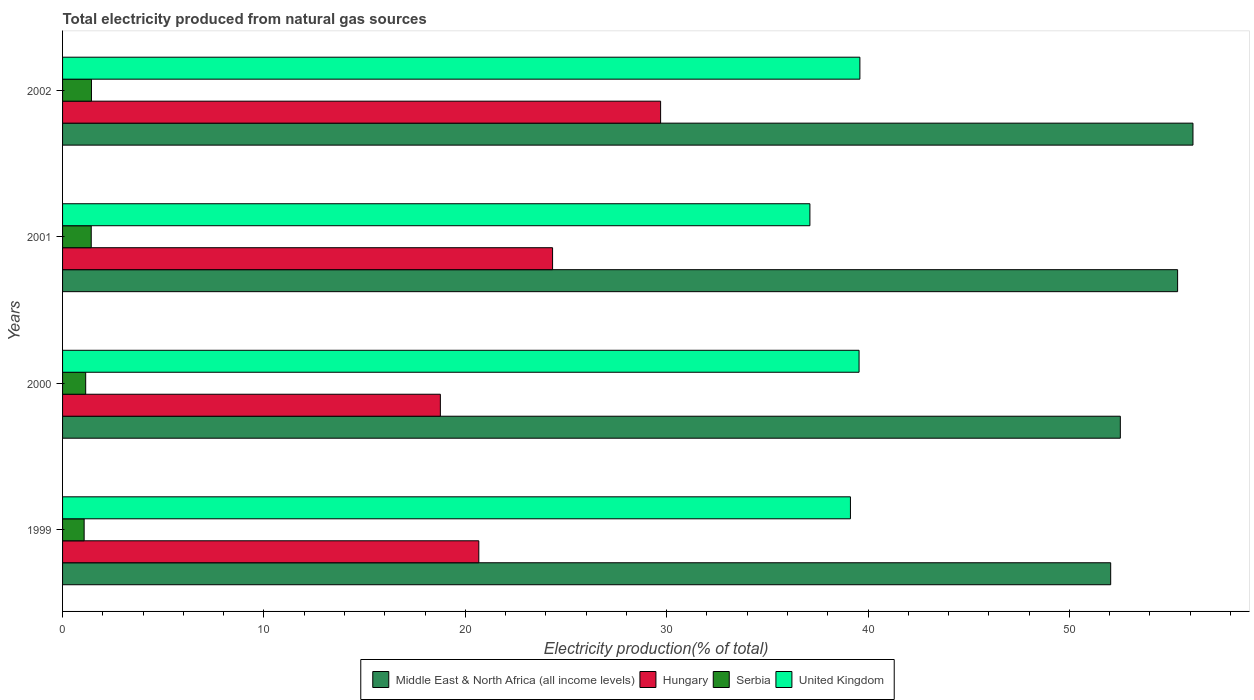How many bars are there on the 3rd tick from the bottom?
Give a very brief answer. 4. What is the label of the 2nd group of bars from the top?
Your response must be concise. 2001. In how many cases, is the number of bars for a given year not equal to the number of legend labels?
Provide a succinct answer. 0. What is the total electricity produced in Serbia in 1999?
Provide a succinct answer. 1.07. Across all years, what is the maximum total electricity produced in Hungary?
Give a very brief answer. 29.7. Across all years, what is the minimum total electricity produced in Middle East & North Africa (all income levels)?
Your answer should be compact. 52.05. In which year was the total electricity produced in Serbia maximum?
Offer a very short reply. 2002. In which year was the total electricity produced in Serbia minimum?
Your answer should be very brief. 1999. What is the total total electricity produced in United Kingdom in the graph?
Provide a succinct answer. 155.38. What is the difference between the total electricity produced in Hungary in 1999 and that in 2002?
Ensure brevity in your answer.  -9.03. What is the difference between the total electricity produced in Serbia in 1999 and the total electricity produced in Hungary in 2002?
Offer a terse response. -28.63. What is the average total electricity produced in Hungary per year?
Keep it short and to the point. 23.37. In the year 2000, what is the difference between the total electricity produced in Middle East & North Africa (all income levels) and total electricity produced in United Kingdom?
Your answer should be compact. 12.97. In how many years, is the total electricity produced in Serbia greater than 24 %?
Offer a very short reply. 0. What is the ratio of the total electricity produced in United Kingdom in 1999 to that in 2000?
Make the answer very short. 0.99. Is the total electricity produced in United Kingdom in 2000 less than that in 2002?
Ensure brevity in your answer.  Yes. What is the difference between the highest and the second highest total electricity produced in Serbia?
Give a very brief answer. 0.01. What is the difference between the highest and the lowest total electricity produced in United Kingdom?
Ensure brevity in your answer.  2.48. In how many years, is the total electricity produced in United Kingdom greater than the average total electricity produced in United Kingdom taken over all years?
Give a very brief answer. 3. Is the sum of the total electricity produced in Middle East & North Africa (all income levels) in 1999 and 2001 greater than the maximum total electricity produced in Hungary across all years?
Your answer should be compact. Yes. What does the 2nd bar from the top in 2001 represents?
Your response must be concise. Serbia. What does the 4th bar from the bottom in 2000 represents?
Your response must be concise. United Kingdom. How many bars are there?
Keep it short and to the point. 16. How many years are there in the graph?
Make the answer very short. 4. What is the difference between two consecutive major ticks on the X-axis?
Give a very brief answer. 10. Does the graph contain grids?
Your answer should be very brief. No. Where does the legend appear in the graph?
Ensure brevity in your answer.  Bottom center. How many legend labels are there?
Keep it short and to the point. 4. What is the title of the graph?
Make the answer very short. Total electricity produced from natural gas sources. What is the label or title of the X-axis?
Keep it short and to the point. Electricity production(% of total). What is the Electricity production(% of total) in Middle East & North Africa (all income levels) in 1999?
Your answer should be compact. 52.05. What is the Electricity production(% of total) of Hungary in 1999?
Give a very brief answer. 20.67. What is the Electricity production(% of total) in Serbia in 1999?
Ensure brevity in your answer.  1.07. What is the Electricity production(% of total) in United Kingdom in 1999?
Ensure brevity in your answer.  39.12. What is the Electricity production(% of total) in Middle East & North Africa (all income levels) in 2000?
Provide a succinct answer. 52.53. What is the Electricity production(% of total) of Hungary in 2000?
Your answer should be compact. 18.76. What is the Electricity production(% of total) of Serbia in 2000?
Offer a very short reply. 1.15. What is the Electricity production(% of total) in United Kingdom in 2000?
Provide a succinct answer. 39.55. What is the Electricity production(% of total) of Middle East & North Africa (all income levels) in 2001?
Make the answer very short. 55.37. What is the Electricity production(% of total) of Hungary in 2001?
Offer a very short reply. 24.33. What is the Electricity production(% of total) in Serbia in 2001?
Offer a terse response. 1.42. What is the Electricity production(% of total) of United Kingdom in 2001?
Offer a terse response. 37.11. What is the Electricity production(% of total) of Middle East & North Africa (all income levels) in 2002?
Offer a very short reply. 56.13. What is the Electricity production(% of total) in Hungary in 2002?
Offer a terse response. 29.7. What is the Electricity production(% of total) in Serbia in 2002?
Provide a short and direct response. 1.43. What is the Electricity production(% of total) in United Kingdom in 2002?
Provide a succinct answer. 39.59. Across all years, what is the maximum Electricity production(% of total) in Middle East & North Africa (all income levels)?
Offer a very short reply. 56.13. Across all years, what is the maximum Electricity production(% of total) in Hungary?
Give a very brief answer. 29.7. Across all years, what is the maximum Electricity production(% of total) in Serbia?
Ensure brevity in your answer.  1.43. Across all years, what is the maximum Electricity production(% of total) of United Kingdom?
Make the answer very short. 39.59. Across all years, what is the minimum Electricity production(% of total) in Middle East & North Africa (all income levels)?
Provide a short and direct response. 52.05. Across all years, what is the minimum Electricity production(% of total) of Hungary?
Ensure brevity in your answer.  18.76. Across all years, what is the minimum Electricity production(% of total) of Serbia?
Provide a short and direct response. 1.07. Across all years, what is the minimum Electricity production(% of total) in United Kingdom?
Keep it short and to the point. 37.11. What is the total Electricity production(% of total) in Middle East & North Africa (all income levels) in the graph?
Provide a succinct answer. 216.08. What is the total Electricity production(% of total) in Hungary in the graph?
Keep it short and to the point. 93.46. What is the total Electricity production(% of total) in Serbia in the graph?
Your answer should be very brief. 5.08. What is the total Electricity production(% of total) of United Kingdom in the graph?
Provide a succinct answer. 155.38. What is the difference between the Electricity production(% of total) of Middle East & North Africa (all income levels) in 1999 and that in 2000?
Your response must be concise. -0.48. What is the difference between the Electricity production(% of total) in Hungary in 1999 and that in 2000?
Give a very brief answer. 1.91. What is the difference between the Electricity production(% of total) of Serbia in 1999 and that in 2000?
Provide a succinct answer. -0.08. What is the difference between the Electricity production(% of total) of United Kingdom in 1999 and that in 2000?
Give a very brief answer. -0.43. What is the difference between the Electricity production(% of total) in Middle East & North Africa (all income levels) in 1999 and that in 2001?
Your answer should be very brief. -3.32. What is the difference between the Electricity production(% of total) in Hungary in 1999 and that in 2001?
Make the answer very short. -3.66. What is the difference between the Electricity production(% of total) of Serbia in 1999 and that in 2001?
Your answer should be compact. -0.35. What is the difference between the Electricity production(% of total) in United Kingdom in 1999 and that in 2001?
Give a very brief answer. 2.01. What is the difference between the Electricity production(% of total) of Middle East & North Africa (all income levels) in 1999 and that in 2002?
Provide a succinct answer. -4.09. What is the difference between the Electricity production(% of total) in Hungary in 1999 and that in 2002?
Your answer should be very brief. -9.03. What is the difference between the Electricity production(% of total) in Serbia in 1999 and that in 2002?
Offer a terse response. -0.36. What is the difference between the Electricity production(% of total) of United Kingdom in 1999 and that in 2002?
Make the answer very short. -0.47. What is the difference between the Electricity production(% of total) in Middle East & North Africa (all income levels) in 2000 and that in 2001?
Provide a succinct answer. -2.84. What is the difference between the Electricity production(% of total) in Hungary in 2000 and that in 2001?
Ensure brevity in your answer.  -5.57. What is the difference between the Electricity production(% of total) in Serbia in 2000 and that in 2001?
Ensure brevity in your answer.  -0.28. What is the difference between the Electricity production(% of total) in United Kingdom in 2000 and that in 2001?
Offer a very short reply. 2.44. What is the difference between the Electricity production(% of total) in Middle East & North Africa (all income levels) in 2000 and that in 2002?
Ensure brevity in your answer.  -3.61. What is the difference between the Electricity production(% of total) of Hungary in 2000 and that in 2002?
Your response must be concise. -10.94. What is the difference between the Electricity production(% of total) in Serbia in 2000 and that in 2002?
Your response must be concise. -0.29. What is the difference between the Electricity production(% of total) in United Kingdom in 2000 and that in 2002?
Your response must be concise. -0.04. What is the difference between the Electricity production(% of total) of Middle East & North Africa (all income levels) in 2001 and that in 2002?
Offer a very short reply. -0.76. What is the difference between the Electricity production(% of total) of Hungary in 2001 and that in 2002?
Keep it short and to the point. -5.36. What is the difference between the Electricity production(% of total) of Serbia in 2001 and that in 2002?
Offer a very short reply. -0.01. What is the difference between the Electricity production(% of total) in United Kingdom in 2001 and that in 2002?
Give a very brief answer. -2.48. What is the difference between the Electricity production(% of total) of Middle East & North Africa (all income levels) in 1999 and the Electricity production(% of total) of Hungary in 2000?
Offer a very short reply. 33.29. What is the difference between the Electricity production(% of total) in Middle East & North Africa (all income levels) in 1999 and the Electricity production(% of total) in Serbia in 2000?
Offer a very short reply. 50.9. What is the difference between the Electricity production(% of total) in Middle East & North Africa (all income levels) in 1999 and the Electricity production(% of total) in United Kingdom in 2000?
Make the answer very short. 12.49. What is the difference between the Electricity production(% of total) of Hungary in 1999 and the Electricity production(% of total) of Serbia in 2000?
Ensure brevity in your answer.  19.52. What is the difference between the Electricity production(% of total) of Hungary in 1999 and the Electricity production(% of total) of United Kingdom in 2000?
Provide a succinct answer. -18.88. What is the difference between the Electricity production(% of total) in Serbia in 1999 and the Electricity production(% of total) in United Kingdom in 2000?
Offer a very short reply. -38.48. What is the difference between the Electricity production(% of total) of Middle East & North Africa (all income levels) in 1999 and the Electricity production(% of total) of Hungary in 2001?
Your answer should be compact. 27.71. What is the difference between the Electricity production(% of total) of Middle East & North Africa (all income levels) in 1999 and the Electricity production(% of total) of Serbia in 2001?
Your response must be concise. 50.62. What is the difference between the Electricity production(% of total) of Middle East & North Africa (all income levels) in 1999 and the Electricity production(% of total) of United Kingdom in 2001?
Your response must be concise. 14.94. What is the difference between the Electricity production(% of total) of Hungary in 1999 and the Electricity production(% of total) of Serbia in 2001?
Your answer should be compact. 19.25. What is the difference between the Electricity production(% of total) of Hungary in 1999 and the Electricity production(% of total) of United Kingdom in 2001?
Give a very brief answer. -16.44. What is the difference between the Electricity production(% of total) in Serbia in 1999 and the Electricity production(% of total) in United Kingdom in 2001?
Provide a short and direct response. -36.04. What is the difference between the Electricity production(% of total) of Middle East & North Africa (all income levels) in 1999 and the Electricity production(% of total) of Hungary in 2002?
Your answer should be compact. 22.35. What is the difference between the Electricity production(% of total) of Middle East & North Africa (all income levels) in 1999 and the Electricity production(% of total) of Serbia in 2002?
Your answer should be very brief. 50.61. What is the difference between the Electricity production(% of total) in Middle East & North Africa (all income levels) in 1999 and the Electricity production(% of total) in United Kingdom in 2002?
Your answer should be very brief. 12.45. What is the difference between the Electricity production(% of total) of Hungary in 1999 and the Electricity production(% of total) of Serbia in 2002?
Make the answer very short. 19.24. What is the difference between the Electricity production(% of total) of Hungary in 1999 and the Electricity production(% of total) of United Kingdom in 2002?
Keep it short and to the point. -18.92. What is the difference between the Electricity production(% of total) of Serbia in 1999 and the Electricity production(% of total) of United Kingdom in 2002?
Offer a very short reply. -38.52. What is the difference between the Electricity production(% of total) in Middle East & North Africa (all income levels) in 2000 and the Electricity production(% of total) in Hungary in 2001?
Ensure brevity in your answer.  28.19. What is the difference between the Electricity production(% of total) in Middle East & North Africa (all income levels) in 2000 and the Electricity production(% of total) in Serbia in 2001?
Ensure brevity in your answer.  51.1. What is the difference between the Electricity production(% of total) of Middle East & North Africa (all income levels) in 2000 and the Electricity production(% of total) of United Kingdom in 2001?
Your answer should be very brief. 15.41. What is the difference between the Electricity production(% of total) in Hungary in 2000 and the Electricity production(% of total) in Serbia in 2001?
Your answer should be very brief. 17.34. What is the difference between the Electricity production(% of total) of Hungary in 2000 and the Electricity production(% of total) of United Kingdom in 2001?
Make the answer very short. -18.35. What is the difference between the Electricity production(% of total) in Serbia in 2000 and the Electricity production(% of total) in United Kingdom in 2001?
Offer a very short reply. -35.96. What is the difference between the Electricity production(% of total) of Middle East & North Africa (all income levels) in 2000 and the Electricity production(% of total) of Hungary in 2002?
Provide a short and direct response. 22.83. What is the difference between the Electricity production(% of total) of Middle East & North Africa (all income levels) in 2000 and the Electricity production(% of total) of Serbia in 2002?
Your answer should be compact. 51.09. What is the difference between the Electricity production(% of total) of Middle East & North Africa (all income levels) in 2000 and the Electricity production(% of total) of United Kingdom in 2002?
Give a very brief answer. 12.93. What is the difference between the Electricity production(% of total) in Hungary in 2000 and the Electricity production(% of total) in Serbia in 2002?
Offer a very short reply. 17.33. What is the difference between the Electricity production(% of total) of Hungary in 2000 and the Electricity production(% of total) of United Kingdom in 2002?
Keep it short and to the point. -20.83. What is the difference between the Electricity production(% of total) of Serbia in 2000 and the Electricity production(% of total) of United Kingdom in 2002?
Provide a succinct answer. -38.45. What is the difference between the Electricity production(% of total) of Middle East & North Africa (all income levels) in 2001 and the Electricity production(% of total) of Hungary in 2002?
Your answer should be compact. 25.67. What is the difference between the Electricity production(% of total) of Middle East & North Africa (all income levels) in 2001 and the Electricity production(% of total) of Serbia in 2002?
Your answer should be very brief. 53.94. What is the difference between the Electricity production(% of total) of Middle East & North Africa (all income levels) in 2001 and the Electricity production(% of total) of United Kingdom in 2002?
Your answer should be compact. 15.78. What is the difference between the Electricity production(% of total) of Hungary in 2001 and the Electricity production(% of total) of Serbia in 2002?
Give a very brief answer. 22.9. What is the difference between the Electricity production(% of total) in Hungary in 2001 and the Electricity production(% of total) in United Kingdom in 2002?
Offer a terse response. -15.26. What is the difference between the Electricity production(% of total) in Serbia in 2001 and the Electricity production(% of total) in United Kingdom in 2002?
Provide a short and direct response. -38.17. What is the average Electricity production(% of total) of Middle East & North Africa (all income levels) per year?
Provide a short and direct response. 54.02. What is the average Electricity production(% of total) of Hungary per year?
Provide a succinct answer. 23.37. What is the average Electricity production(% of total) of Serbia per year?
Provide a short and direct response. 1.27. What is the average Electricity production(% of total) in United Kingdom per year?
Provide a short and direct response. 38.85. In the year 1999, what is the difference between the Electricity production(% of total) in Middle East & North Africa (all income levels) and Electricity production(% of total) in Hungary?
Offer a very short reply. 31.38. In the year 1999, what is the difference between the Electricity production(% of total) in Middle East & North Africa (all income levels) and Electricity production(% of total) in Serbia?
Offer a very short reply. 50.98. In the year 1999, what is the difference between the Electricity production(% of total) of Middle East & North Africa (all income levels) and Electricity production(% of total) of United Kingdom?
Ensure brevity in your answer.  12.92. In the year 1999, what is the difference between the Electricity production(% of total) of Hungary and Electricity production(% of total) of Serbia?
Ensure brevity in your answer.  19.6. In the year 1999, what is the difference between the Electricity production(% of total) in Hungary and Electricity production(% of total) in United Kingdom?
Give a very brief answer. -18.45. In the year 1999, what is the difference between the Electricity production(% of total) in Serbia and Electricity production(% of total) in United Kingdom?
Your answer should be compact. -38.05. In the year 2000, what is the difference between the Electricity production(% of total) in Middle East & North Africa (all income levels) and Electricity production(% of total) in Hungary?
Ensure brevity in your answer.  33.77. In the year 2000, what is the difference between the Electricity production(% of total) of Middle East & North Africa (all income levels) and Electricity production(% of total) of Serbia?
Give a very brief answer. 51.38. In the year 2000, what is the difference between the Electricity production(% of total) of Middle East & North Africa (all income levels) and Electricity production(% of total) of United Kingdom?
Provide a succinct answer. 12.97. In the year 2000, what is the difference between the Electricity production(% of total) in Hungary and Electricity production(% of total) in Serbia?
Make the answer very short. 17.61. In the year 2000, what is the difference between the Electricity production(% of total) in Hungary and Electricity production(% of total) in United Kingdom?
Your answer should be very brief. -20.79. In the year 2000, what is the difference between the Electricity production(% of total) in Serbia and Electricity production(% of total) in United Kingdom?
Provide a short and direct response. -38.4. In the year 2001, what is the difference between the Electricity production(% of total) in Middle East & North Africa (all income levels) and Electricity production(% of total) in Hungary?
Keep it short and to the point. 31.04. In the year 2001, what is the difference between the Electricity production(% of total) of Middle East & North Africa (all income levels) and Electricity production(% of total) of Serbia?
Make the answer very short. 53.95. In the year 2001, what is the difference between the Electricity production(% of total) of Middle East & North Africa (all income levels) and Electricity production(% of total) of United Kingdom?
Ensure brevity in your answer.  18.26. In the year 2001, what is the difference between the Electricity production(% of total) in Hungary and Electricity production(% of total) in Serbia?
Keep it short and to the point. 22.91. In the year 2001, what is the difference between the Electricity production(% of total) in Hungary and Electricity production(% of total) in United Kingdom?
Give a very brief answer. -12.78. In the year 2001, what is the difference between the Electricity production(% of total) of Serbia and Electricity production(% of total) of United Kingdom?
Give a very brief answer. -35.69. In the year 2002, what is the difference between the Electricity production(% of total) of Middle East & North Africa (all income levels) and Electricity production(% of total) of Hungary?
Offer a very short reply. 26.44. In the year 2002, what is the difference between the Electricity production(% of total) of Middle East & North Africa (all income levels) and Electricity production(% of total) of Serbia?
Your answer should be very brief. 54.7. In the year 2002, what is the difference between the Electricity production(% of total) of Middle East & North Africa (all income levels) and Electricity production(% of total) of United Kingdom?
Provide a short and direct response. 16.54. In the year 2002, what is the difference between the Electricity production(% of total) in Hungary and Electricity production(% of total) in Serbia?
Ensure brevity in your answer.  28.26. In the year 2002, what is the difference between the Electricity production(% of total) in Hungary and Electricity production(% of total) in United Kingdom?
Your answer should be very brief. -9.9. In the year 2002, what is the difference between the Electricity production(% of total) in Serbia and Electricity production(% of total) in United Kingdom?
Give a very brief answer. -38.16. What is the ratio of the Electricity production(% of total) in Middle East & North Africa (all income levels) in 1999 to that in 2000?
Give a very brief answer. 0.99. What is the ratio of the Electricity production(% of total) of Hungary in 1999 to that in 2000?
Provide a succinct answer. 1.1. What is the ratio of the Electricity production(% of total) in Serbia in 1999 to that in 2000?
Provide a succinct answer. 0.93. What is the ratio of the Electricity production(% of total) of Hungary in 1999 to that in 2001?
Offer a terse response. 0.85. What is the ratio of the Electricity production(% of total) of Serbia in 1999 to that in 2001?
Offer a very short reply. 0.75. What is the ratio of the Electricity production(% of total) in United Kingdom in 1999 to that in 2001?
Provide a succinct answer. 1.05. What is the ratio of the Electricity production(% of total) in Middle East & North Africa (all income levels) in 1999 to that in 2002?
Give a very brief answer. 0.93. What is the ratio of the Electricity production(% of total) in Hungary in 1999 to that in 2002?
Give a very brief answer. 0.7. What is the ratio of the Electricity production(% of total) in Serbia in 1999 to that in 2002?
Your answer should be very brief. 0.75. What is the ratio of the Electricity production(% of total) of United Kingdom in 1999 to that in 2002?
Your response must be concise. 0.99. What is the ratio of the Electricity production(% of total) in Middle East & North Africa (all income levels) in 2000 to that in 2001?
Your answer should be compact. 0.95. What is the ratio of the Electricity production(% of total) in Hungary in 2000 to that in 2001?
Provide a short and direct response. 0.77. What is the ratio of the Electricity production(% of total) in Serbia in 2000 to that in 2001?
Make the answer very short. 0.81. What is the ratio of the Electricity production(% of total) of United Kingdom in 2000 to that in 2001?
Offer a terse response. 1.07. What is the ratio of the Electricity production(% of total) of Middle East & North Africa (all income levels) in 2000 to that in 2002?
Offer a very short reply. 0.94. What is the ratio of the Electricity production(% of total) of Hungary in 2000 to that in 2002?
Give a very brief answer. 0.63. What is the ratio of the Electricity production(% of total) of Serbia in 2000 to that in 2002?
Your answer should be very brief. 0.8. What is the ratio of the Electricity production(% of total) of United Kingdom in 2000 to that in 2002?
Ensure brevity in your answer.  1. What is the ratio of the Electricity production(% of total) in Middle East & North Africa (all income levels) in 2001 to that in 2002?
Make the answer very short. 0.99. What is the ratio of the Electricity production(% of total) in Hungary in 2001 to that in 2002?
Provide a succinct answer. 0.82. What is the ratio of the Electricity production(% of total) in Serbia in 2001 to that in 2002?
Ensure brevity in your answer.  0.99. What is the ratio of the Electricity production(% of total) in United Kingdom in 2001 to that in 2002?
Provide a short and direct response. 0.94. What is the difference between the highest and the second highest Electricity production(% of total) of Middle East & North Africa (all income levels)?
Provide a succinct answer. 0.76. What is the difference between the highest and the second highest Electricity production(% of total) in Hungary?
Keep it short and to the point. 5.36. What is the difference between the highest and the second highest Electricity production(% of total) of Serbia?
Keep it short and to the point. 0.01. What is the difference between the highest and the second highest Electricity production(% of total) in United Kingdom?
Your answer should be compact. 0.04. What is the difference between the highest and the lowest Electricity production(% of total) of Middle East & North Africa (all income levels)?
Your response must be concise. 4.09. What is the difference between the highest and the lowest Electricity production(% of total) in Hungary?
Provide a short and direct response. 10.94. What is the difference between the highest and the lowest Electricity production(% of total) in Serbia?
Make the answer very short. 0.36. What is the difference between the highest and the lowest Electricity production(% of total) of United Kingdom?
Provide a short and direct response. 2.48. 